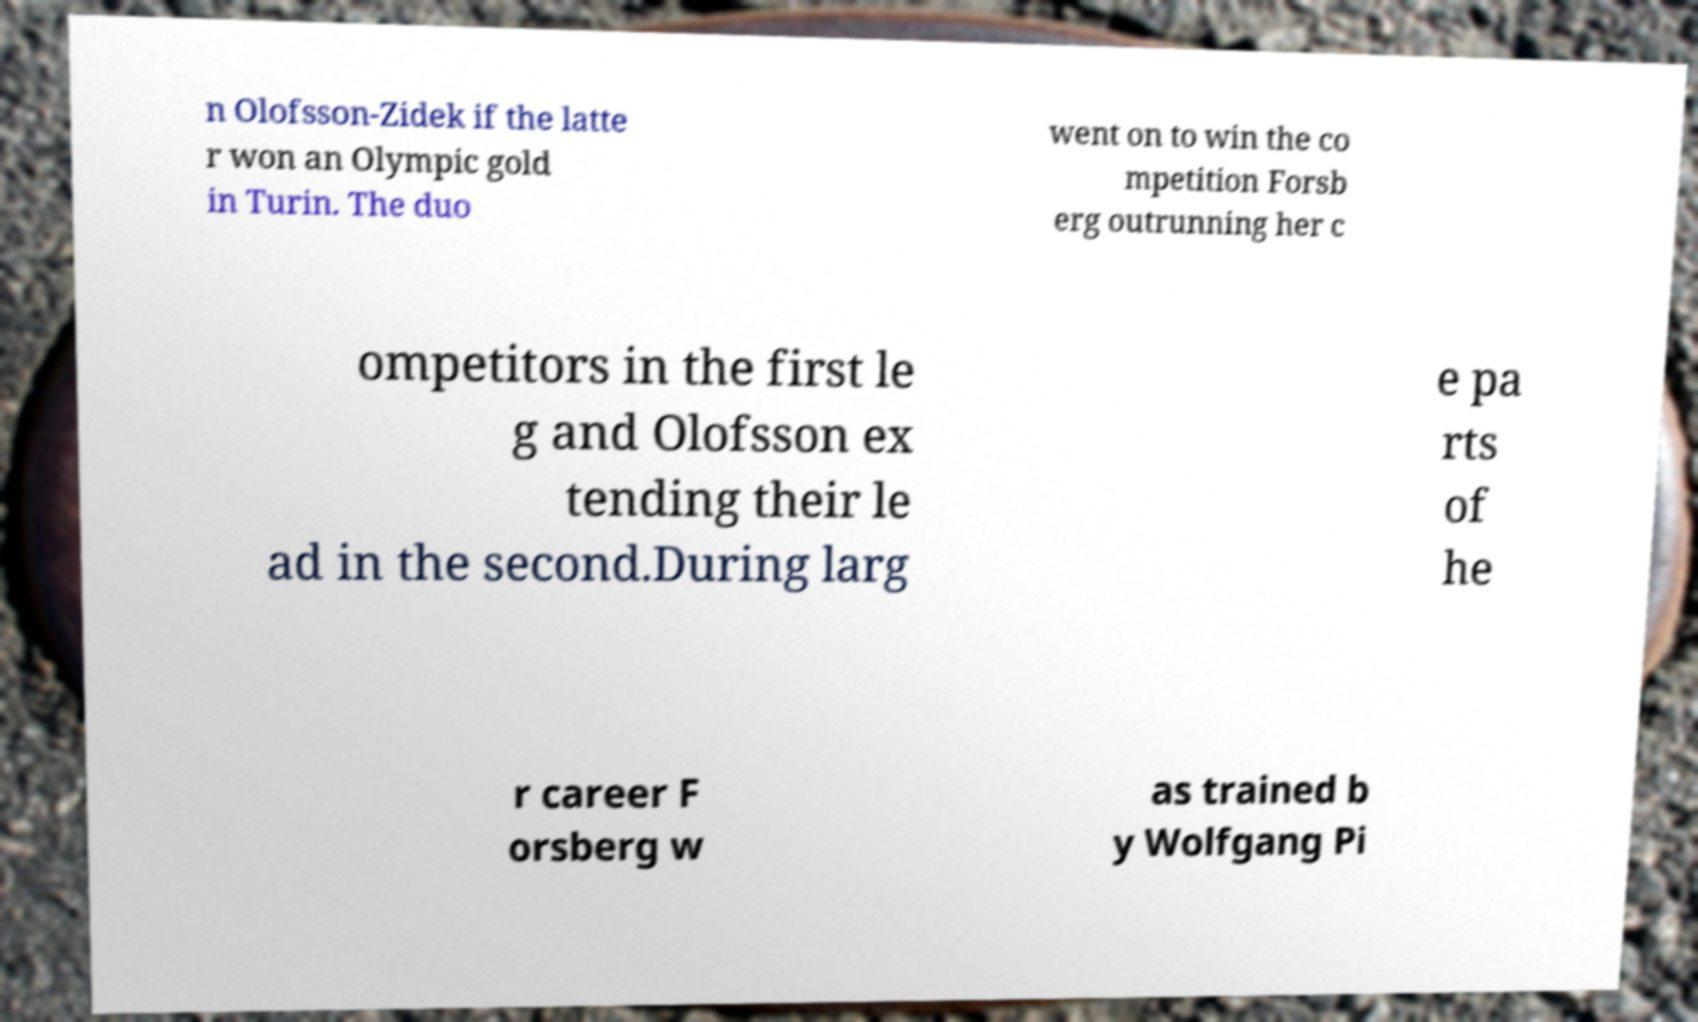What messages or text are displayed in this image? I need them in a readable, typed format. n Olofsson-Zidek if the latte r won an Olympic gold in Turin. The duo went on to win the co mpetition Forsb erg outrunning her c ompetitors in the first le g and Olofsson ex tending their le ad in the second.During larg e pa rts of he r career F orsberg w as trained b y Wolfgang Pi 